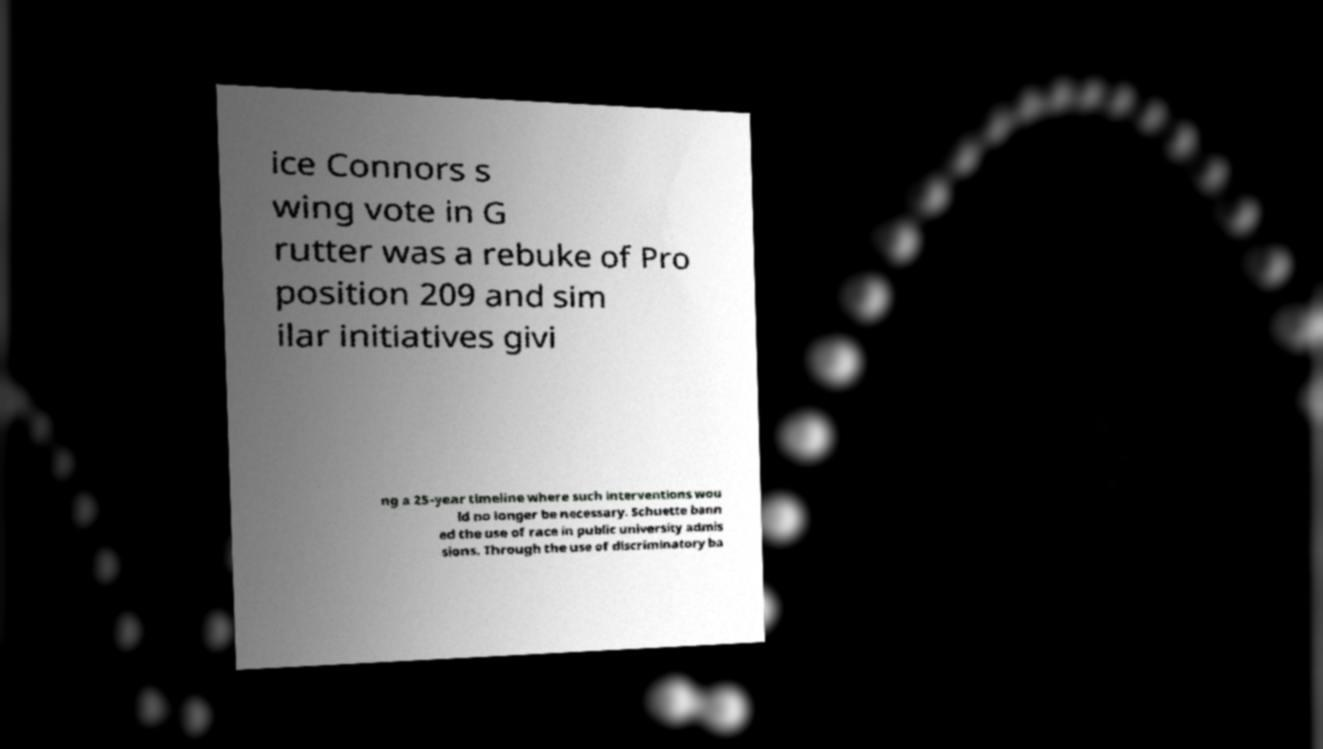For documentation purposes, I need the text within this image transcribed. Could you provide that? ice Connors s wing vote in G rutter was a rebuke of Pro position 209 and sim ilar initiatives givi ng a 25-year timeline where such interventions wou ld no longer be necessary. Schuette bann ed the use of race in public university admis sions. Through the use of discriminatory ba 